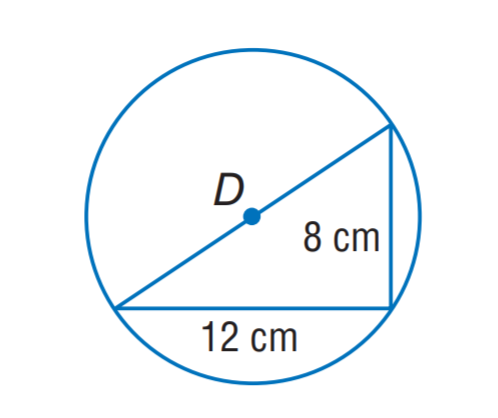Answer the mathemtical geometry problem and directly provide the correct option letter.
Question: The triangle is inscribed in \odot D. Find the exact circumference of \odot D.
Choices: A: 4 \sqrt { 13 } \pi B: 4 \sqrt { 15 } \pi C: 6 \sqrt { 13 } \pi D: 6 \sqrt { 15 } \pi A 